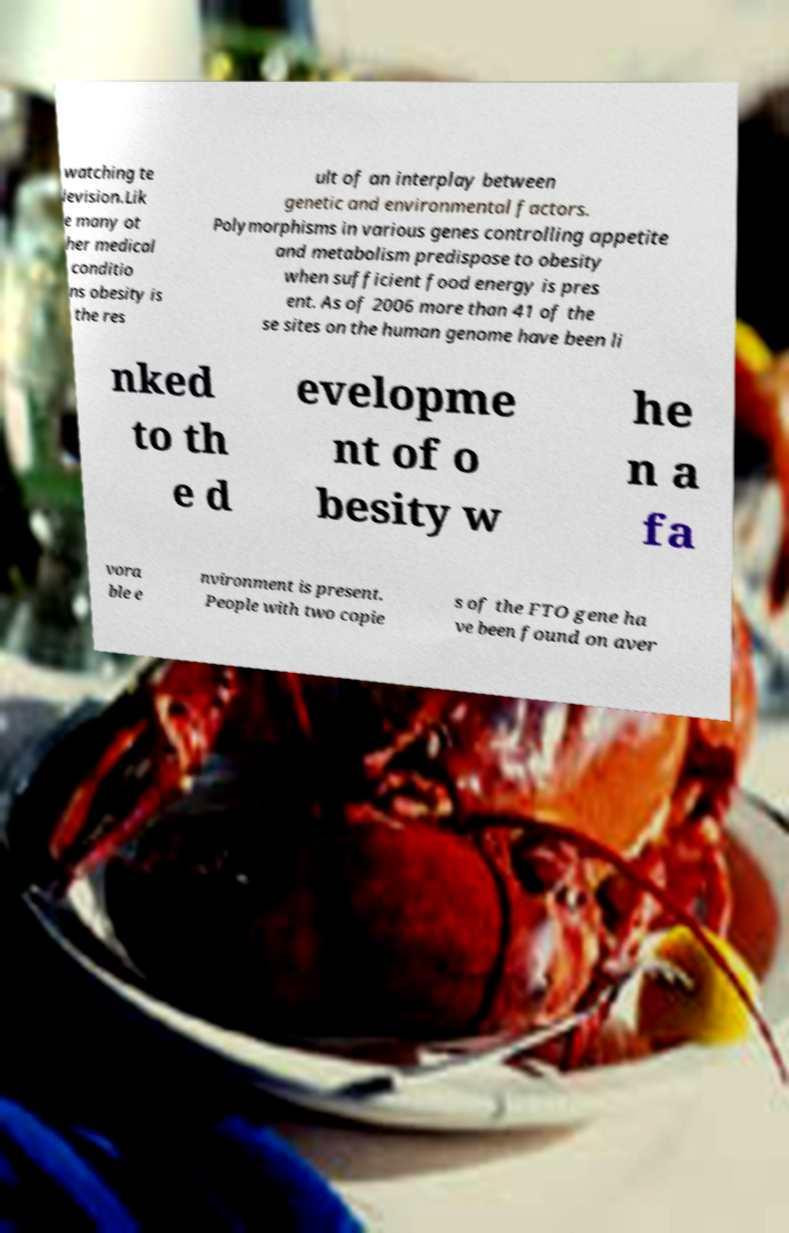For documentation purposes, I need the text within this image transcribed. Could you provide that? watching te levision.Lik e many ot her medical conditio ns obesity is the res ult of an interplay between genetic and environmental factors. Polymorphisms in various genes controlling appetite and metabolism predispose to obesity when sufficient food energy is pres ent. As of 2006 more than 41 of the se sites on the human genome have been li nked to th e d evelopme nt of o besity w he n a fa vora ble e nvironment is present. People with two copie s of the FTO gene ha ve been found on aver 